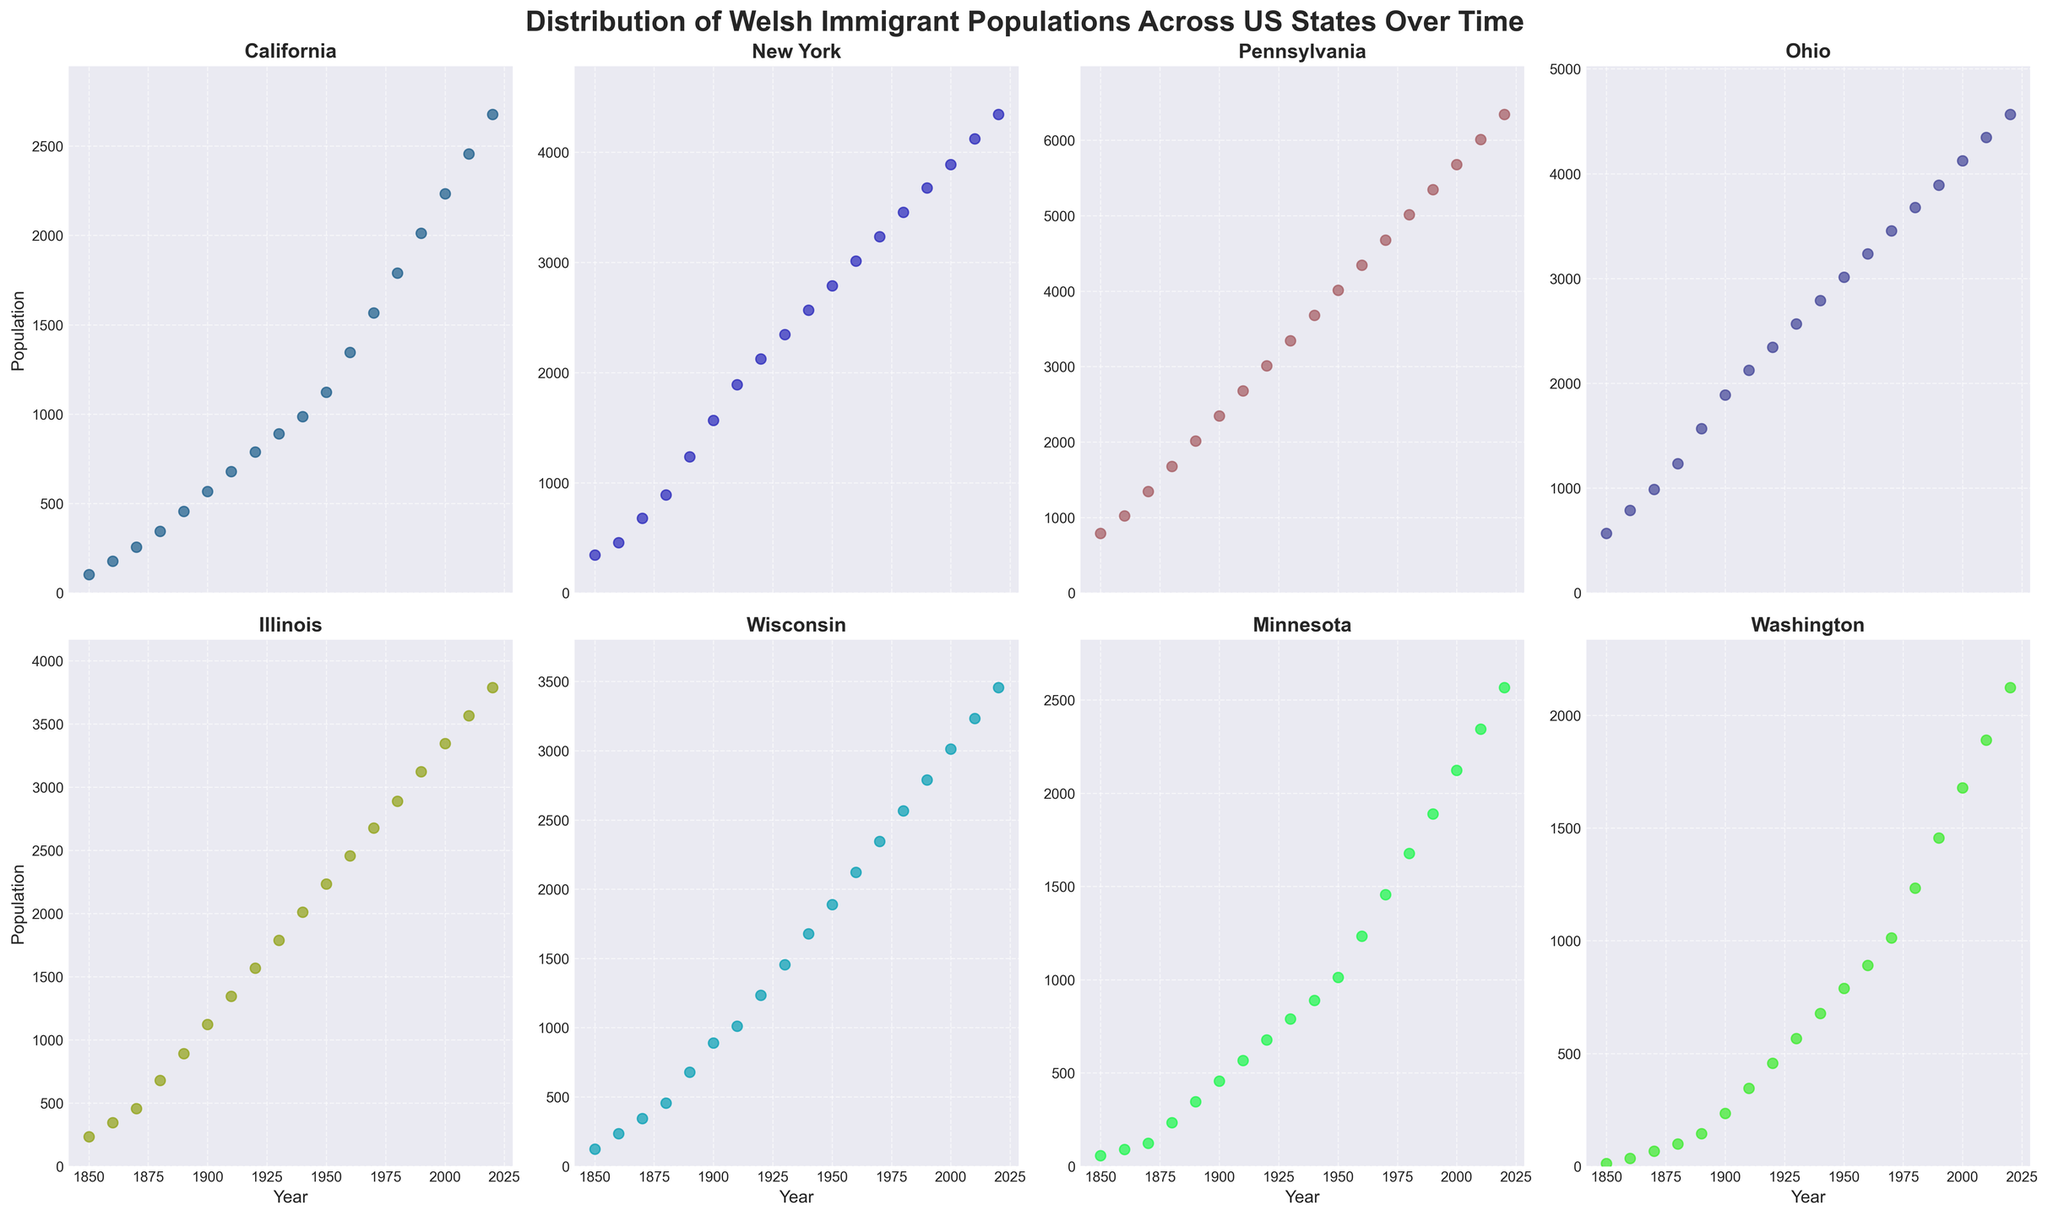What is the general trend in the Welsh immigrant population in California from 1850 to 2020? Observing the scatter plot for California, there is a consistent increase in the population from 1850 to 2020, indicating a steady growth over time.
Answer: Steady increase Which state had the highest Welsh immigrant population in 2020, and what was the population? By looking at the 2020 data points in each subplot, Pennsylvania has the highest population with the data point farthest up the y-axis.
Answer: Pennsylvania, 6345 How did the Welsh immigrant population in Illinois change from 1860 to 1900? In the scatter plot for Illinois, the population increases from roughly 345 in 1860 to 1123 in 1900.
Answer: Increased Compare the Welsh immigrant population trends between Ohio and Minnesota from 1850 to 2020. Which state saw a steeper increase? Observing the scatter plots for Ohio and Minnesota, Ohio shows a more pronounced upward trend compared to the relatively modest increase seen in Minnesota.
Answer: Ohio What is the approximate average population of Welsh immigrants in Wisconsin across all the years presented? Summing up the population values for Wisconsin across all years: (123 + 234 + 345 + 456 + 678 + 890 + 1012 + 1234 + 1456 + 1678 + 1890 + 2123 + 2345 + 2567 + 2789 + 3012 + 3234 + 3456) and dividing by the number of years (18), we get an average.
Answer: 1463.7 Which state shows the smallest population variance over the years? By evaluating the consistency and spread of the data points in each subplot, New York shows the smallest variance with a relatively compact and consistent distribution.
Answer: New York How does the Welsh immigrant population in New York in 1880 compare to that in 1980? From the scatter plot, New York had around 890 Welsh immigrants in 1880 and increased to approximately 3456 in 1980.
Answer: Increased What visual cues suggest that Pennsylvania had significant growth in Welsh immigrant population compared to California? The Pennsylvania subplot has a more steeply rising trend line with higher peaks compared to the relatively smoother and less steep increase in the California subplot.
Answer: Steeper rising trend in Pennsylvania What was the Welsh immigrant population growth rate in Ohio from 1900 to 1950? The population in Ohio grew from 1890 in 1900 to 3012 in 1950. The growth rate can be calculated by (3012 - 1890) / 1890 * 100%.
Answer: 59.37% Estimate the difference in Welsh immigrant populations between Washington and Minnesota in 1920. From the scatter plots, Washington had about 456 immigrants and Minnesota had approximately 678 in 1920. The difference is 678 - 456.
Answer: 222 